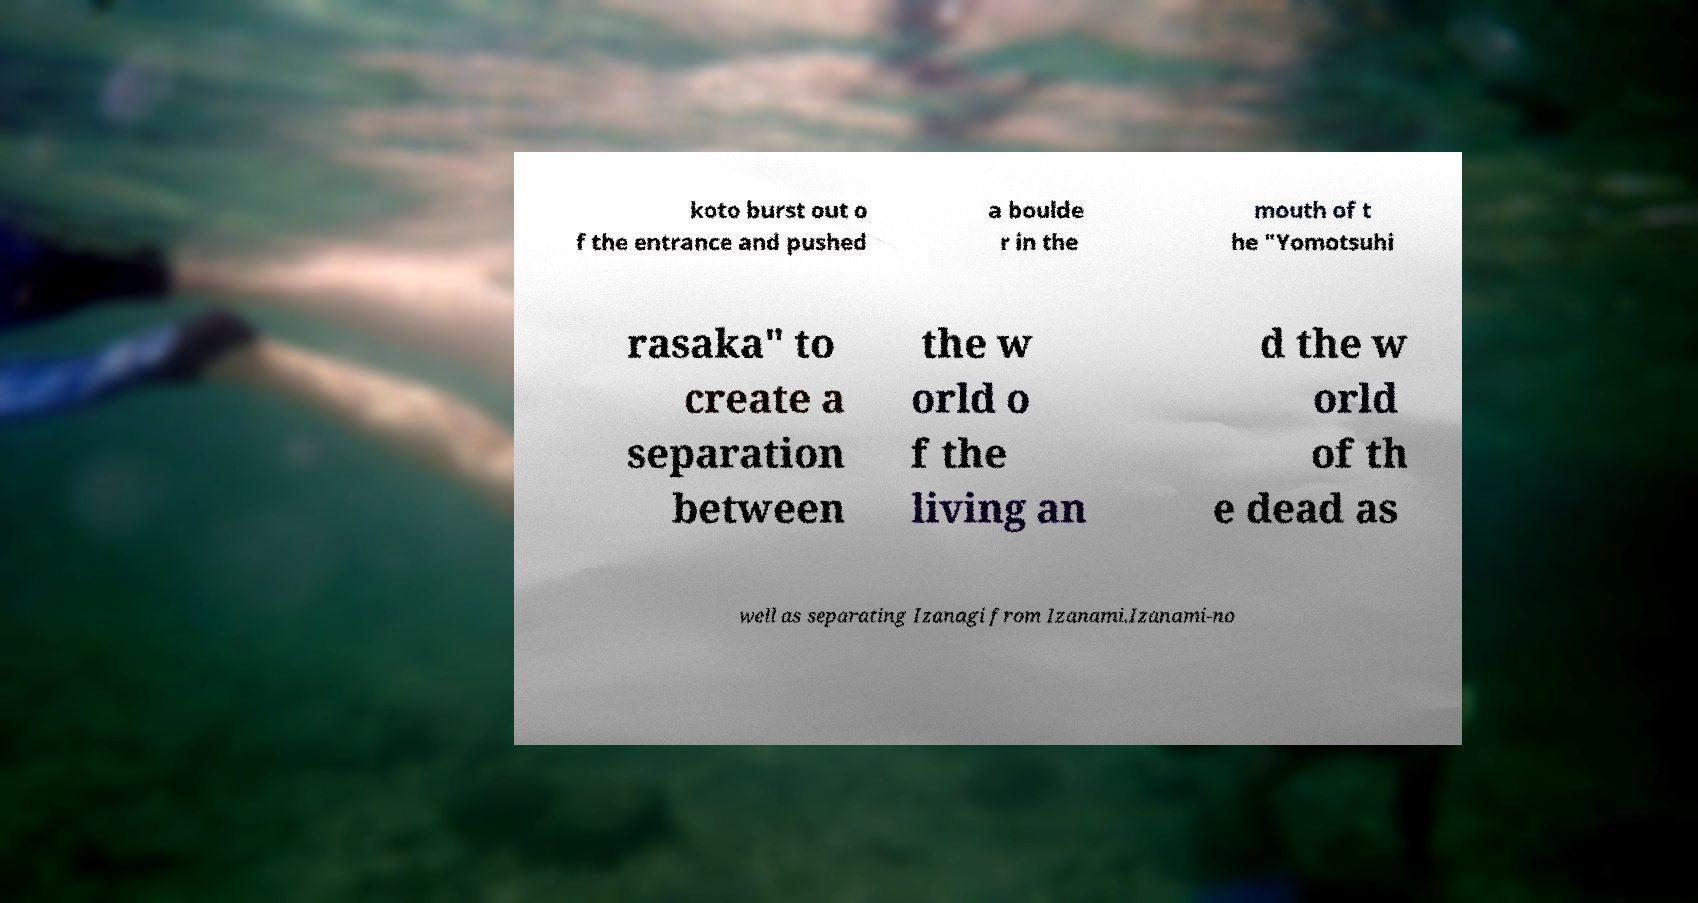There's text embedded in this image that I need extracted. Can you transcribe it verbatim? koto burst out o f the entrance and pushed a boulde r in the mouth of t he "Yomotsuhi rasaka" to create a separation between the w orld o f the living an d the w orld of th e dead as well as separating Izanagi from Izanami.Izanami-no 